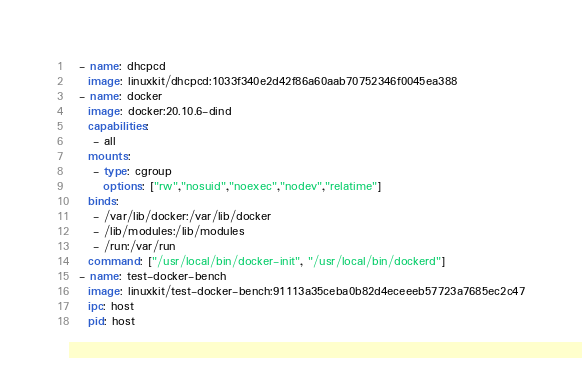<code> <loc_0><loc_0><loc_500><loc_500><_YAML_>  - name: dhcpcd
    image: linuxkit/dhcpcd:1033f340e2d42f86a60aab70752346f0045ea388
  - name: docker
    image: docker:20.10.6-dind
    capabilities:
     - all
    mounts:
     - type: cgroup
       options: ["rw","nosuid","noexec","nodev","relatime"]
    binds:
     - /var/lib/docker:/var/lib/docker
     - /lib/modules:/lib/modules
     - /run:/var/run
    command: ["/usr/local/bin/docker-init", "/usr/local/bin/dockerd"]
  - name: test-docker-bench
    image: linuxkit/test-docker-bench:91113a35ceba0b82d4eceeeb57723a7685ec2c47
    ipc: host
    pid: host</code> 